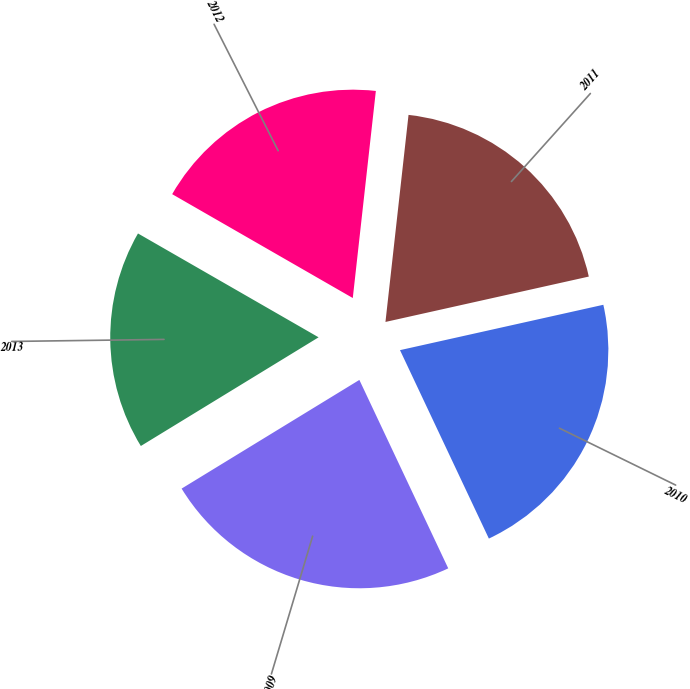Convert chart. <chart><loc_0><loc_0><loc_500><loc_500><pie_chart><fcel>2009<fcel>2010<fcel>2011<fcel>2012<fcel>2013<nl><fcel>23.28%<fcel>21.48%<fcel>19.74%<fcel>18.46%<fcel>17.04%<nl></chart> 